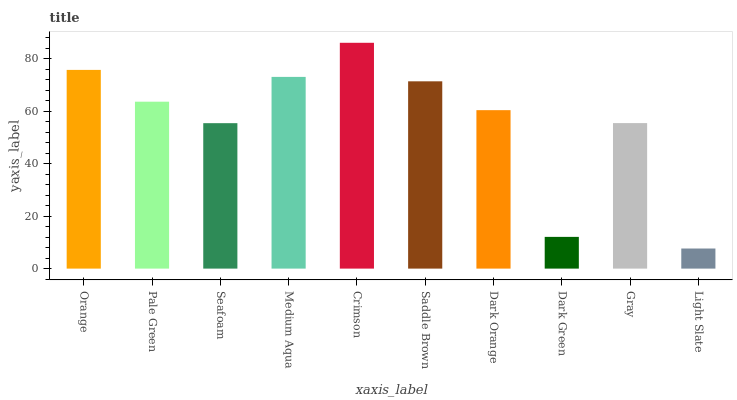Is Light Slate the minimum?
Answer yes or no. Yes. Is Crimson the maximum?
Answer yes or no. Yes. Is Pale Green the minimum?
Answer yes or no. No. Is Pale Green the maximum?
Answer yes or no. No. Is Orange greater than Pale Green?
Answer yes or no. Yes. Is Pale Green less than Orange?
Answer yes or no. Yes. Is Pale Green greater than Orange?
Answer yes or no. No. Is Orange less than Pale Green?
Answer yes or no. No. Is Pale Green the high median?
Answer yes or no. Yes. Is Dark Orange the low median?
Answer yes or no. Yes. Is Orange the high median?
Answer yes or no. No. Is Saddle Brown the low median?
Answer yes or no. No. 